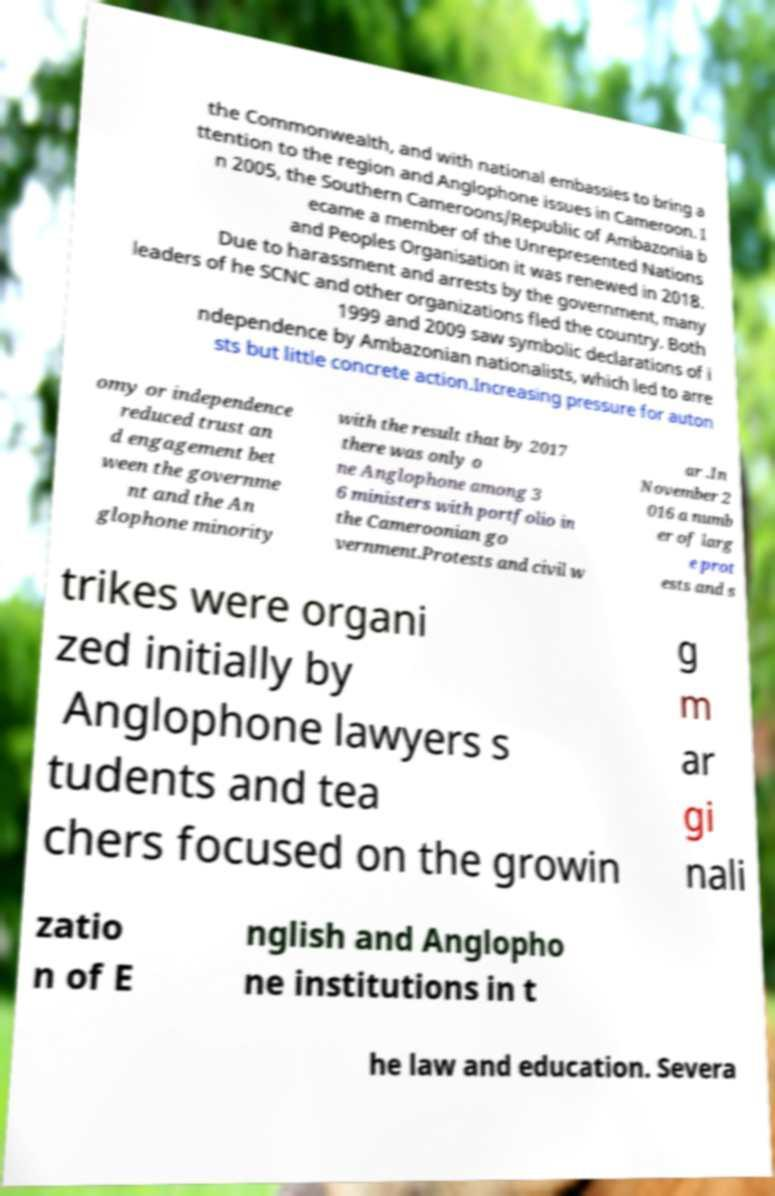Could you extract and type out the text from this image? the Commonwealth, and with national embassies to bring a ttention to the region and Anglophone issues in Cameroon. I n 2005, the Southern Cameroons/Republic of Ambazonia b ecame a member of the Unrepresented Nations and Peoples Organisation it was renewed in 2018. Due to harassment and arrests by the government, many leaders of he SCNC and other organizations fled the country. Both 1999 and 2009 saw symbolic declarations of i ndependence by Ambazonian nationalists, which led to arre sts but little concrete action.Increasing pressure for auton omy or independence reduced trust an d engagement bet ween the governme nt and the An glophone minority with the result that by 2017 there was only o ne Anglophone among 3 6 ministers with portfolio in the Cameroonian go vernment.Protests and civil w ar .In November 2 016 a numb er of larg e prot ests and s trikes were organi zed initially by Anglophone lawyers s tudents and tea chers focused on the growin g m ar gi nali zatio n of E nglish and Anglopho ne institutions in t he law and education. Severa 